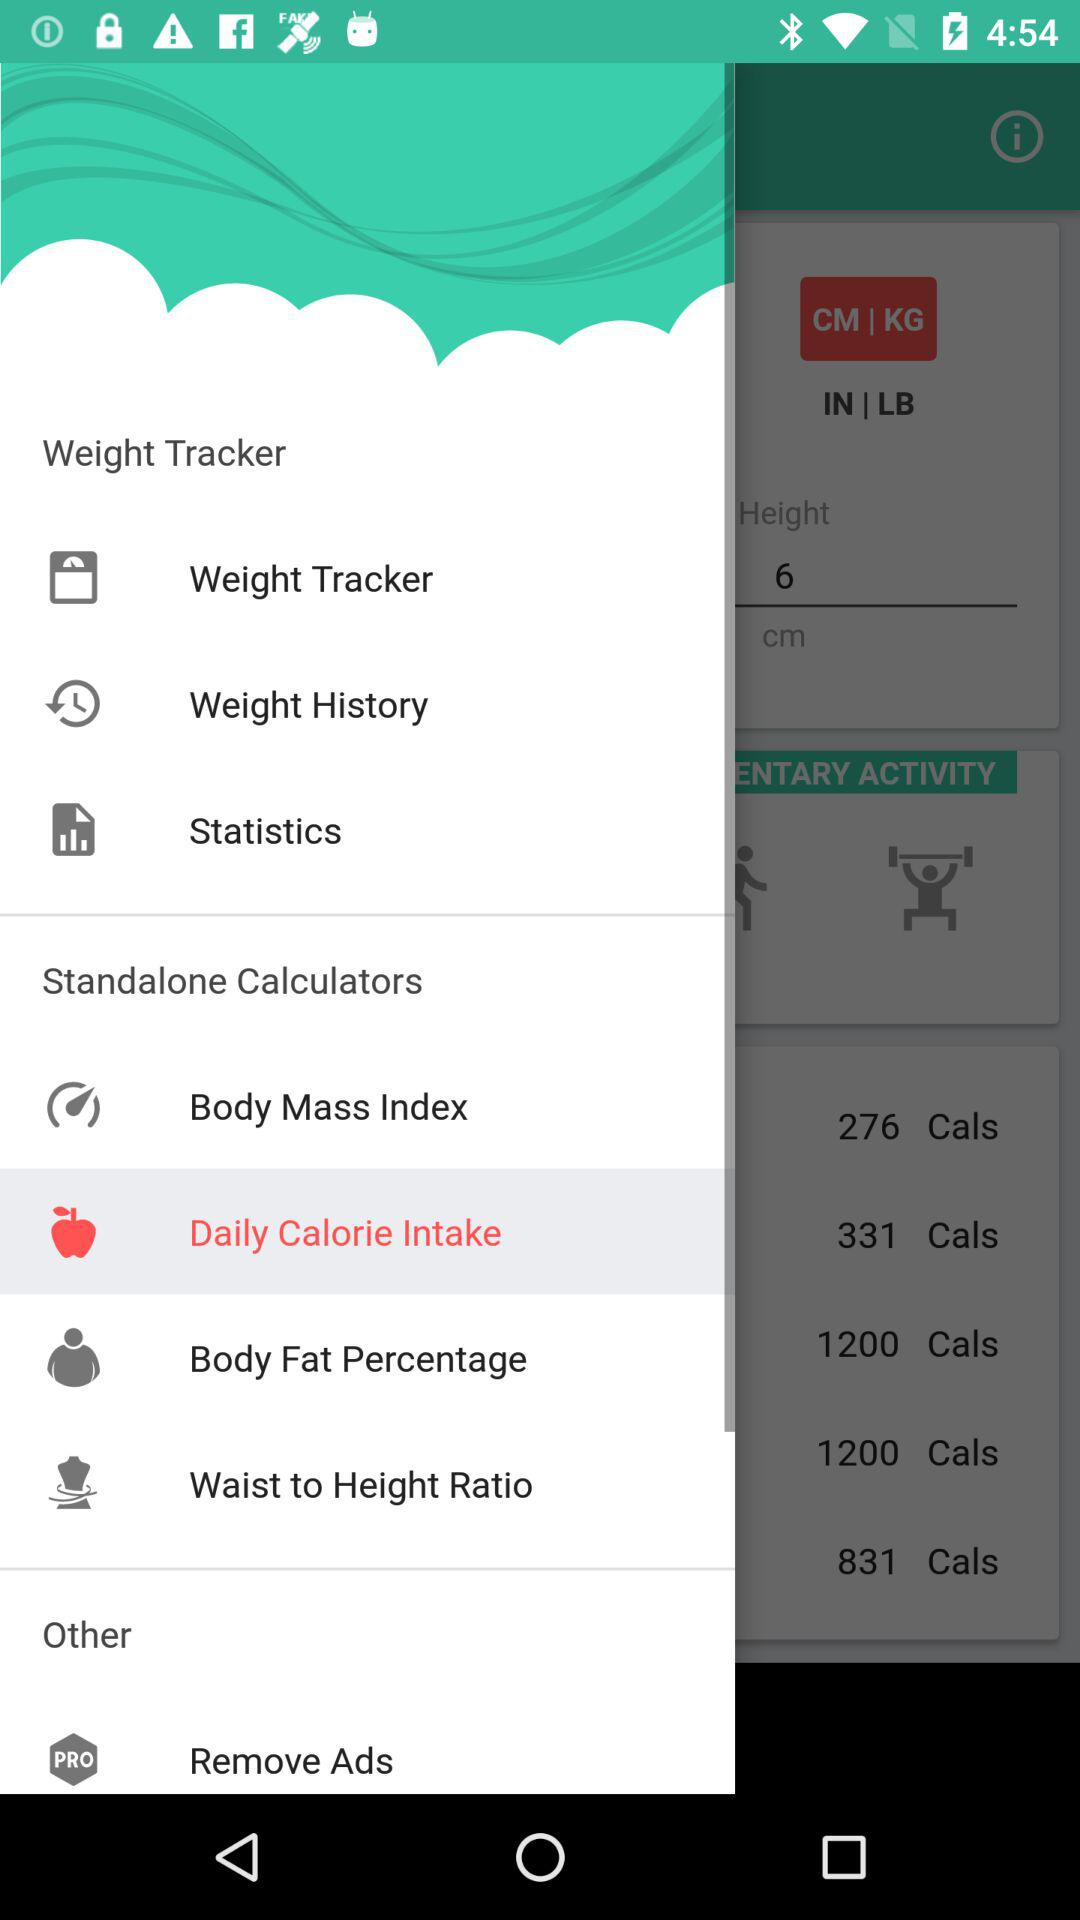Which is the selected item in the menu? The selected item in the menu is "Daily Calorie Intake". 